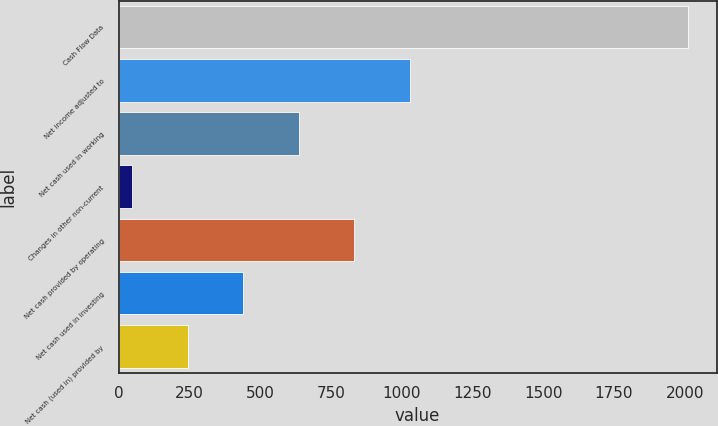Convert chart to OTSL. <chart><loc_0><loc_0><loc_500><loc_500><bar_chart><fcel>Cash Flow Data<fcel>Net income adjusted to<fcel>Net cash used in working<fcel>Changes in other non-current<fcel>Net cash provided by operating<fcel>Net cash used in investing<fcel>Net cash (used in) provided by<nl><fcel>2012<fcel>1029.4<fcel>636.36<fcel>46.8<fcel>832.88<fcel>439.84<fcel>243.32<nl></chart> 